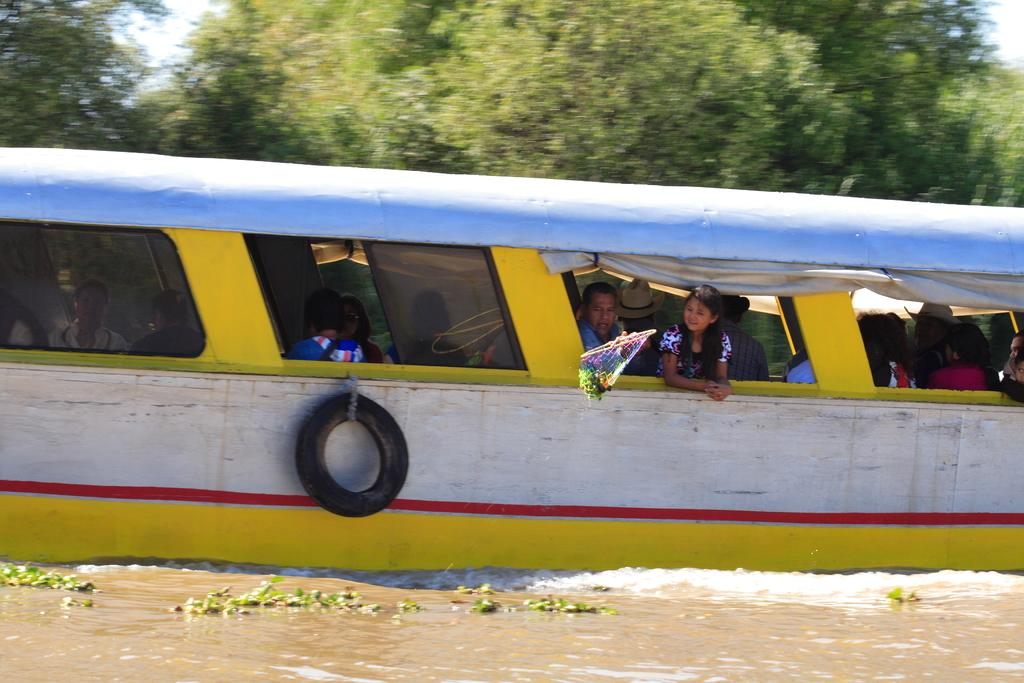What is hanging from the boat in the image? There is a tyre hanging from a boat in the image. What are the people in the boat doing? There are groups of people sitting in the boat. Where is the boat located? The boat is on the water. What can be seen in the background of the image? There are trees and the sky visible in the background of the image. How many boys are learning to smash the tyre in the image? There is no indication of boys learning to smash the tyre in the image. The tyre is simply hanging from the boat, and the people in the boat are sitting. 